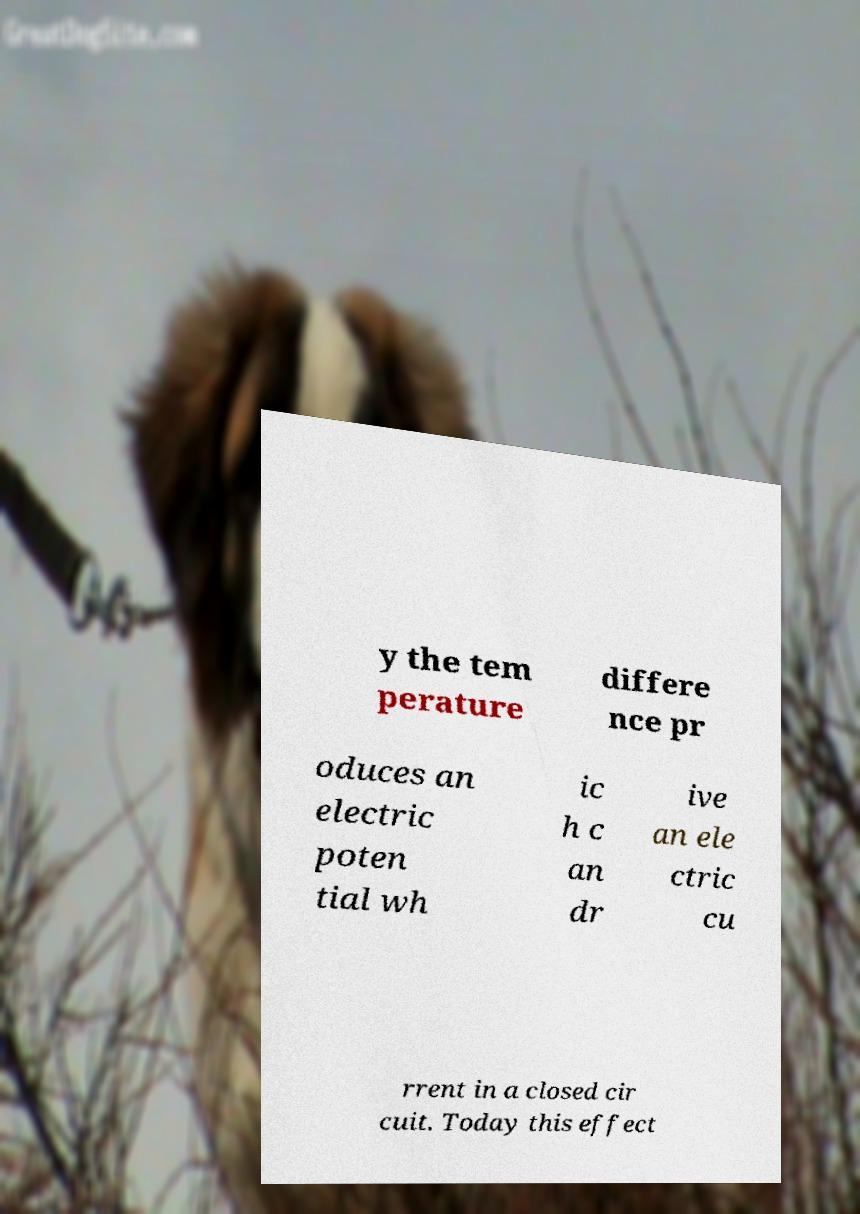Please identify and transcribe the text found in this image. y the tem perature differe nce pr oduces an electric poten tial wh ic h c an dr ive an ele ctric cu rrent in a closed cir cuit. Today this effect 